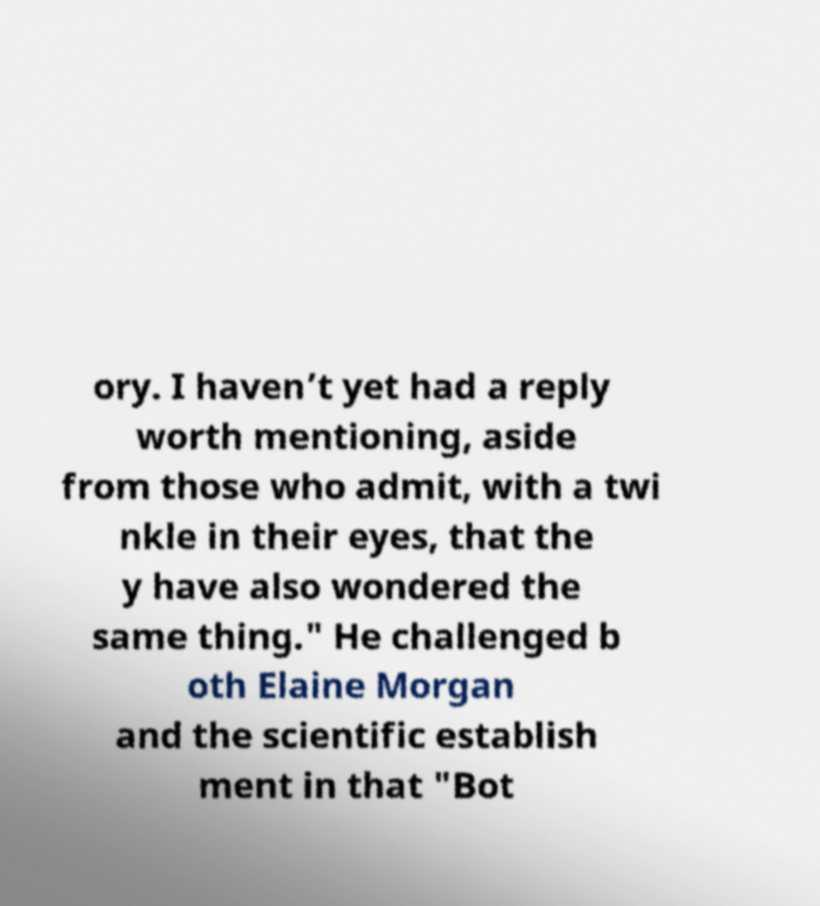I need the written content from this picture converted into text. Can you do that? ory. I haven’t yet had a reply worth mentioning, aside from those who admit, with a twi nkle in their eyes, that the y have also wondered the same thing." He challenged b oth Elaine Morgan and the scientific establish ment in that "Bot 